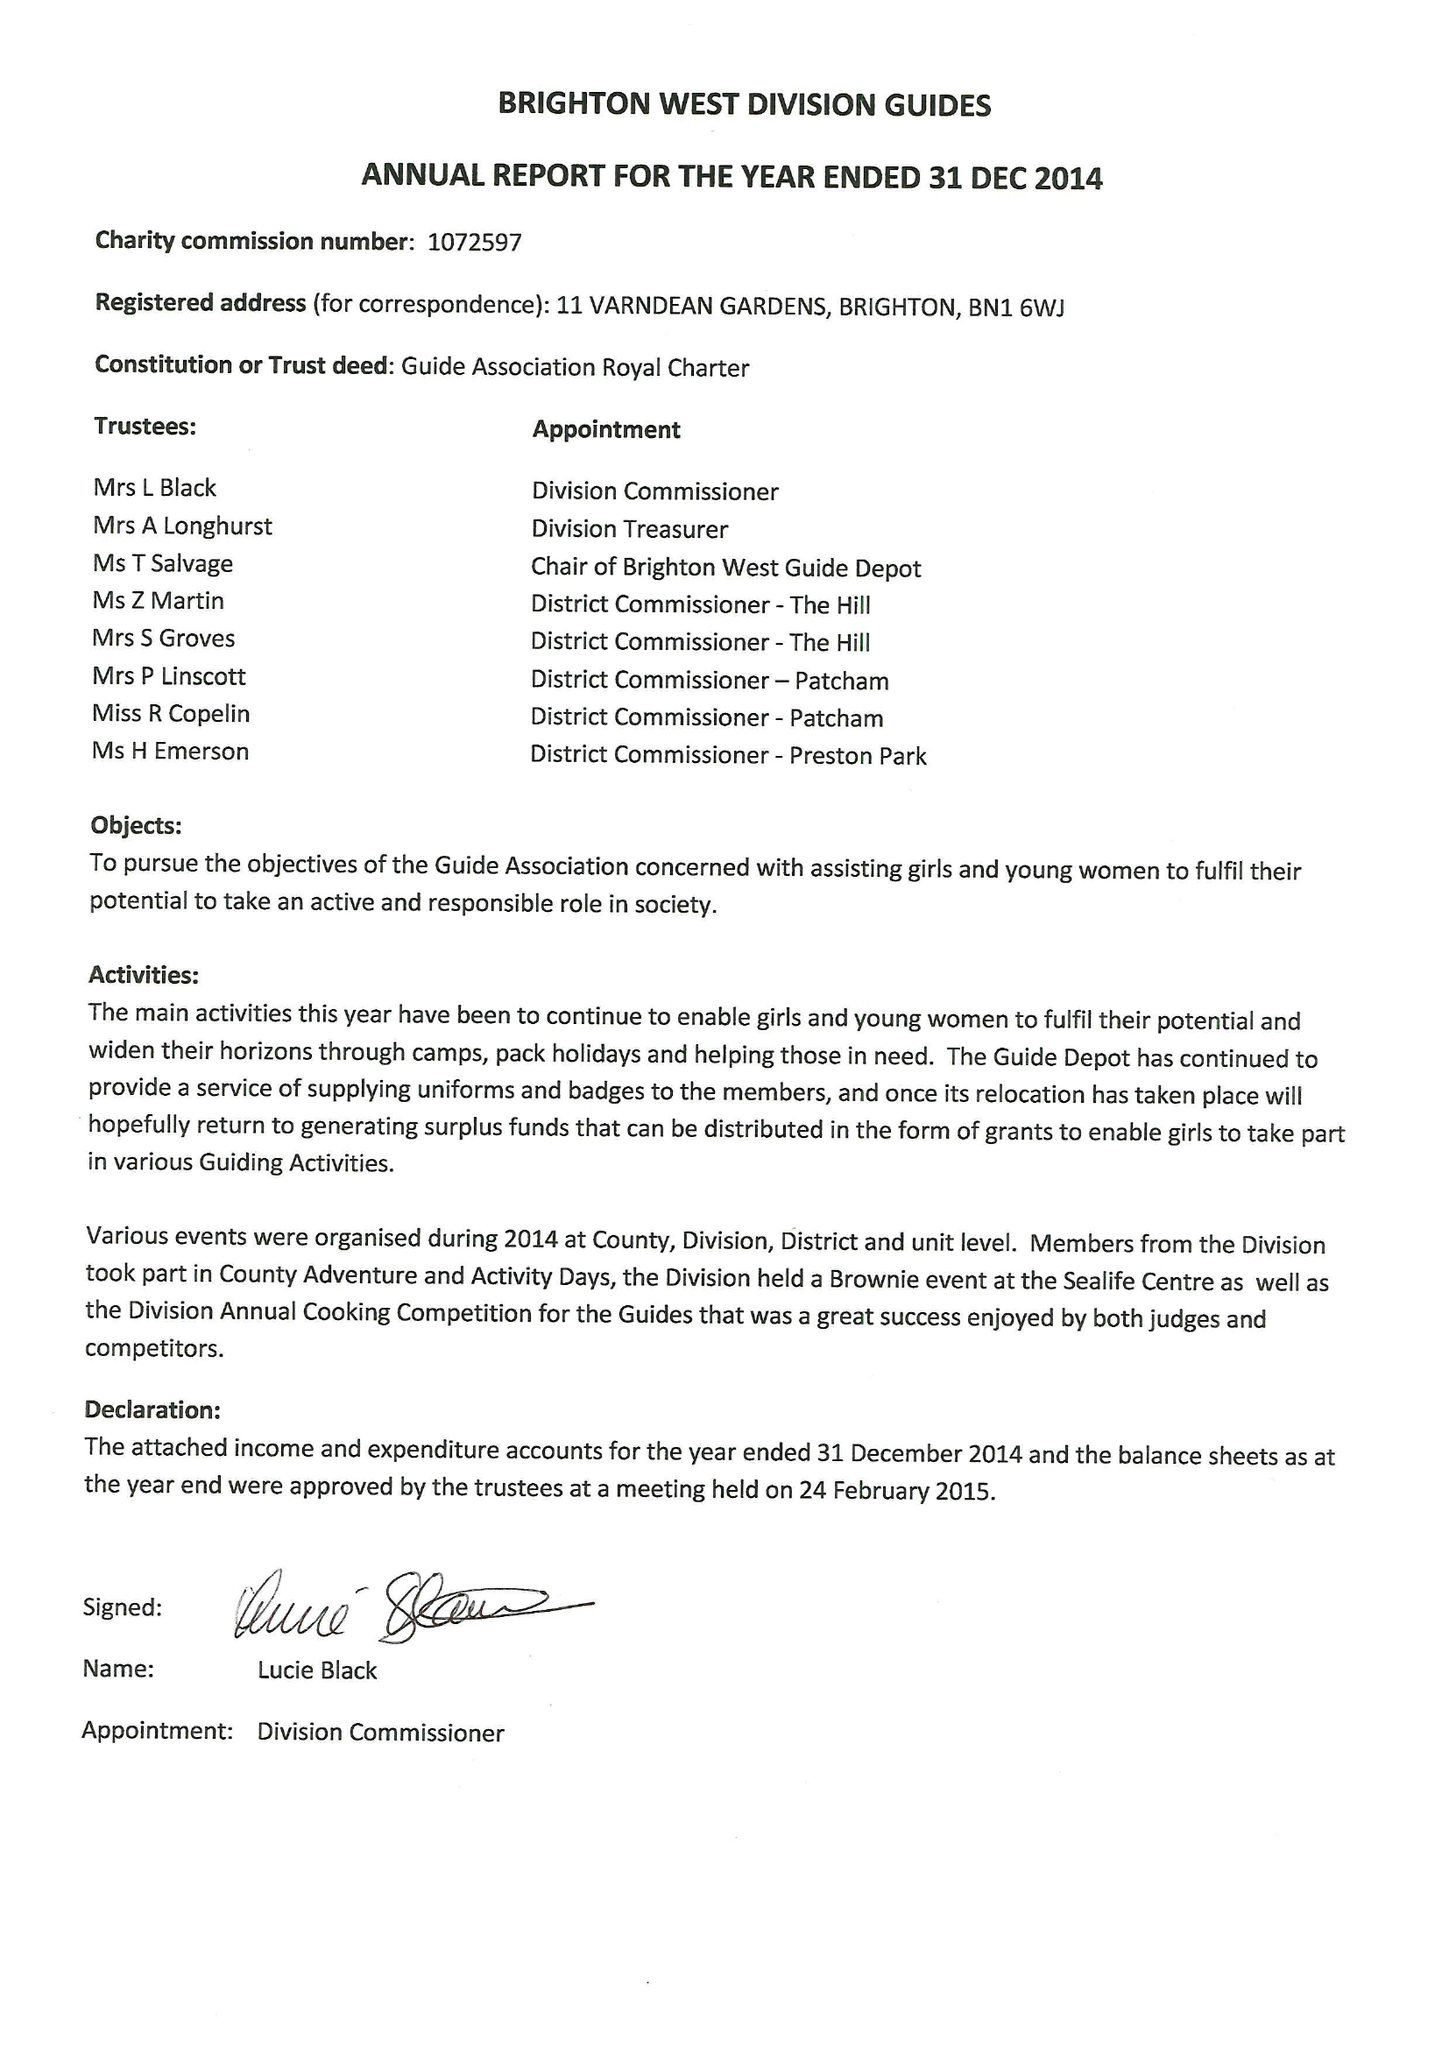What is the value for the address__postcode?
Answer the question using a single word or phrase. BN1 6WJ 